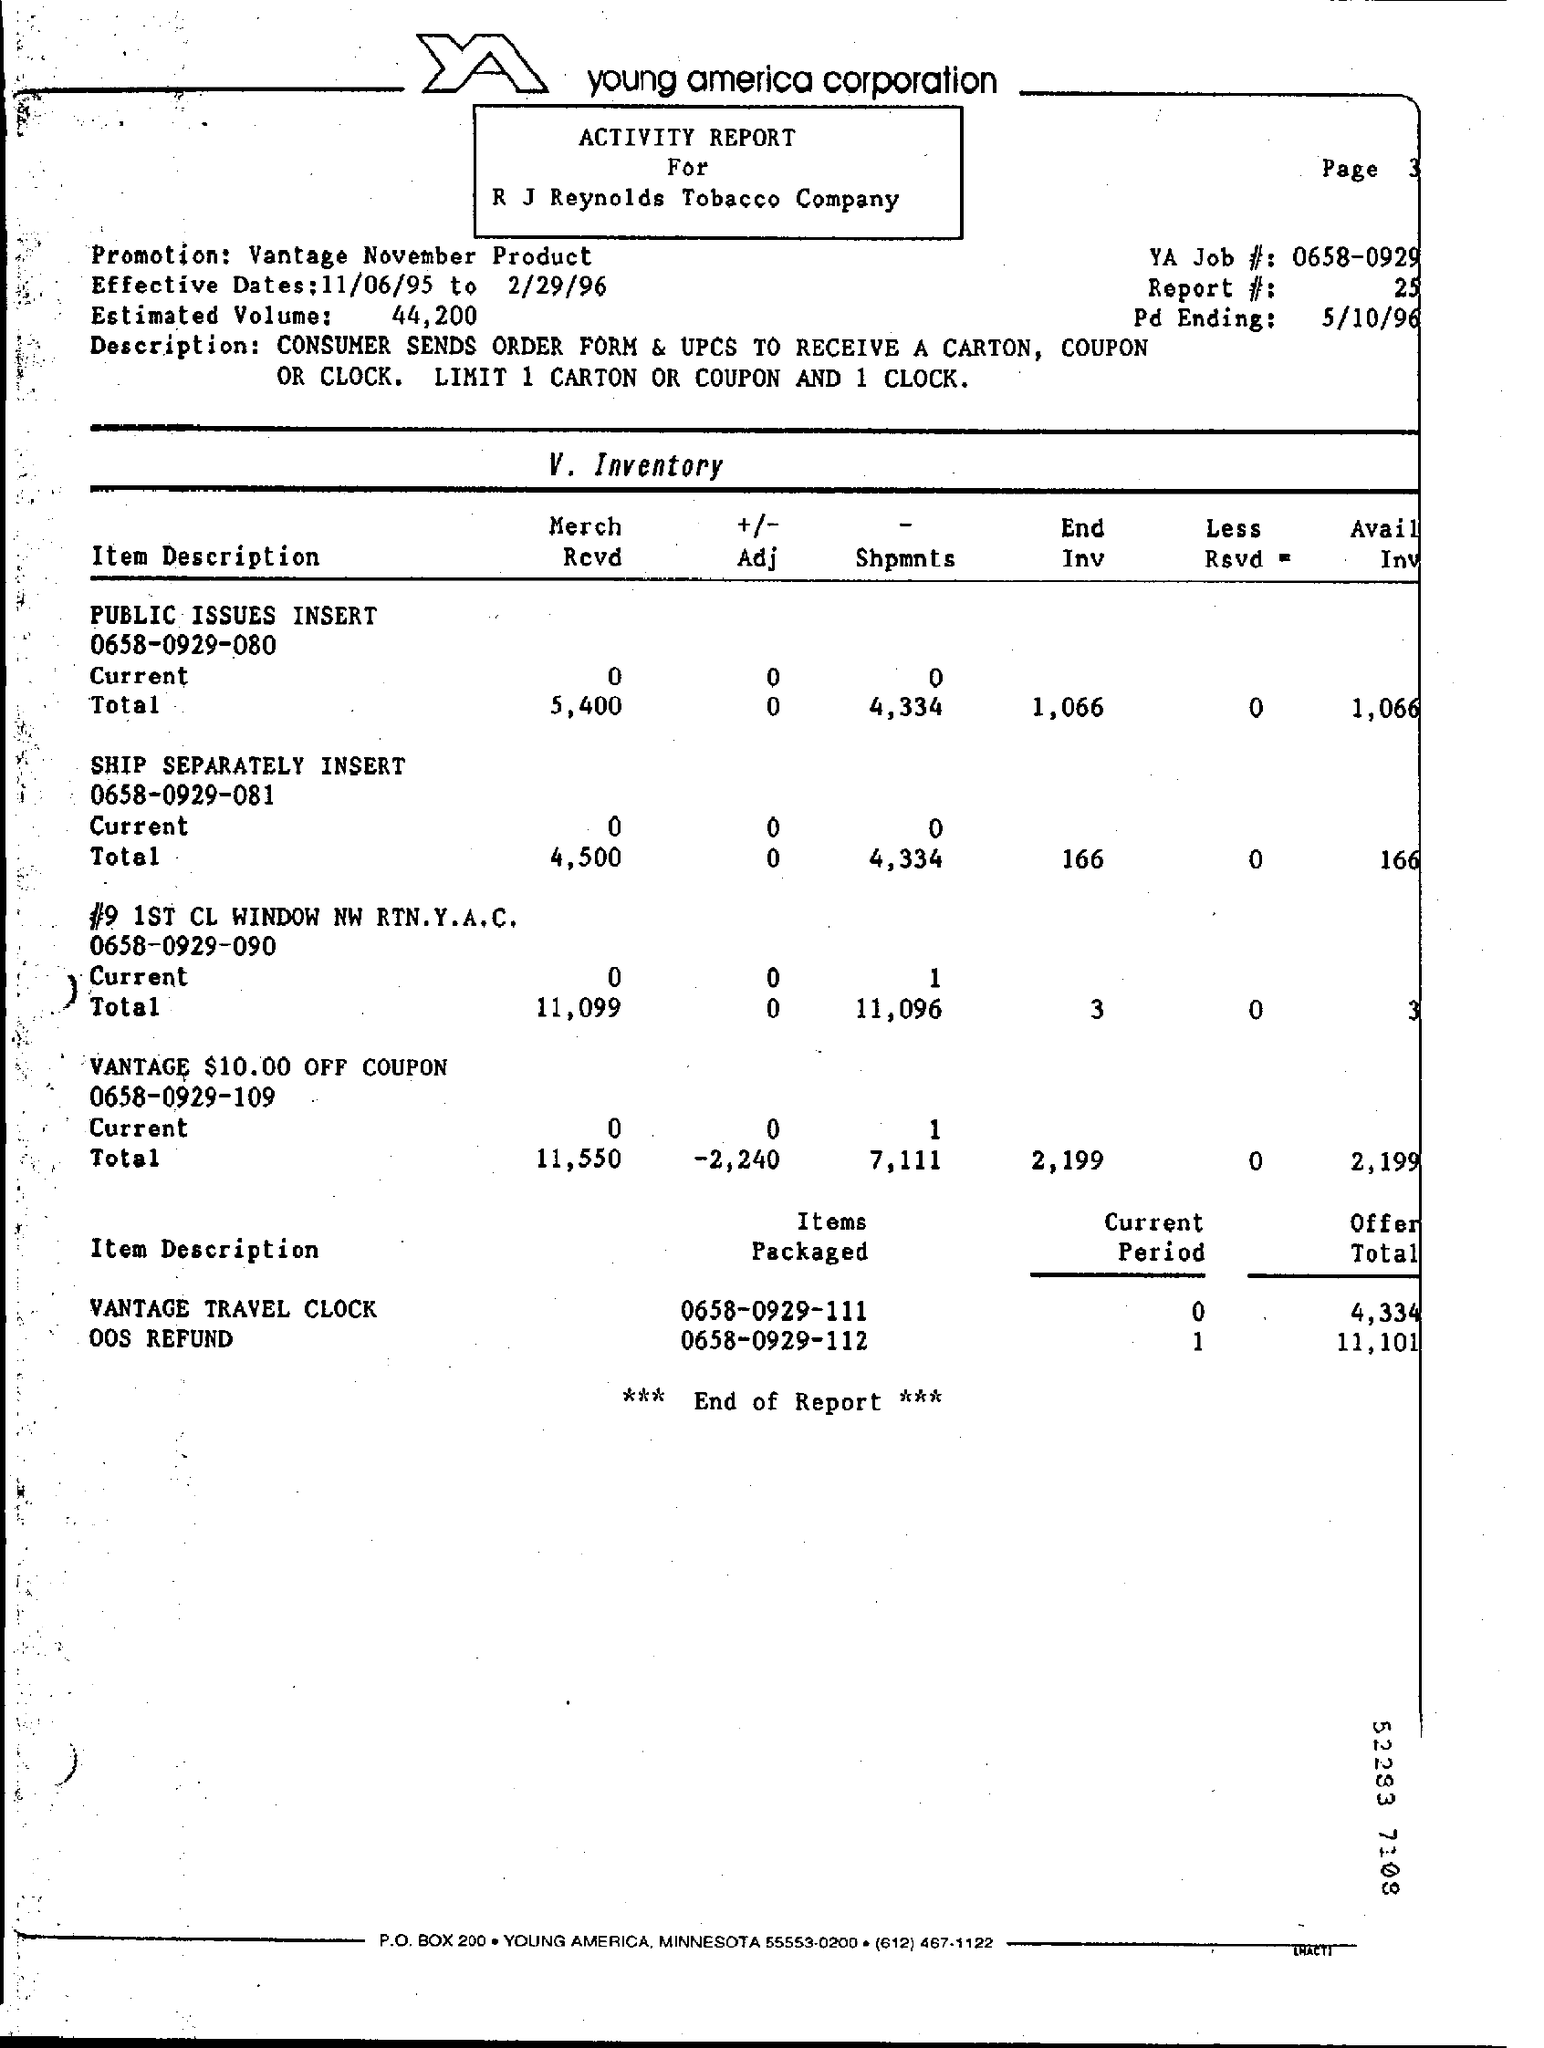What is the Promotion?
Ensure brevity in your answer.  Vantage November Product. What are the Effective Dates?
Offer a terse response. 11/06/95 to 2/29/96. What is the Estimated Volume?
Your response must be concise. 44,200. What is the YA Job#?
Offer a terse response. 0658-0929. What is the Report #?
Your answer should be compact. 25. What is the Pd Ending?
Provide a succinct answer. 5/10/96. What is the Current Period for Vantage Travel Clock?
Keep it short and to the point. 0. What is the Current Period for OOS Refund?
Give a very brief answer. 1. What is the Offer Total for Vantage Travel Clock?
Your answer should be compact. 4,334. 